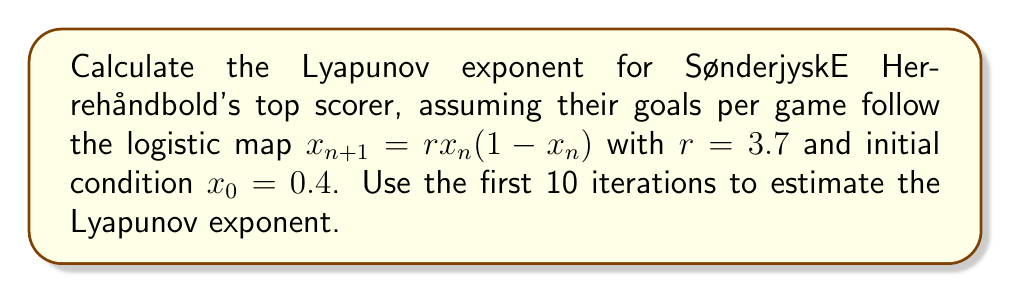Can you answer this question? To calculate the Lyapunov exponent for the player's scoring consistency, we'll follow these steps:

1) The Lyapunov exponent $\lambda$ for the logistic map is given by:

   $$\lambda = \lim_{n \to \infty} \frac{1}{n} \sum_{i=0}^{n-1} \ln |f'(x_i)|$$

   where $f'(x) = r(1-2x)$ for the logistic map.

2) We'll use the first 10 iterations to estimate $\lambda$. First, let's calculate the orbit:

   $x_0 = 0.4$
   $x_1 = 3.7 \cdot 0.4 \cdot (1-0.4) = 0.888$
   $x_2 = 3.7 \cdot 0.888 \cdot (1-0.888) = 0.368$
   $x_3 = 3.7 \cdot 0.368 \cdot (1-0.368) = 0.861$
   $x_4 = 3.7 \cdot 0.861 \cdot (1-0.861) = 0.444$
   $x_5 = 3.7 \cdot 0.444 \cdot (1-0.444) = 0.915$
   $x_6 = 3.7 \cdot 0.915 \cdot (1-0.915) = 0.288$
   $x_7 = 3.7 \cdot 0.288 \cdot (1-0.288) = 0.760$
   $x_8 = 3.7 \cdot 0.760 \cdot (1-0.760) = 0.676$
   $x_9 = 3.7 \cdot 0.676 \cdot (1-0.676) = 0.812$

3) Now, we calculate $|f'(x_i)|$ for each point:

   $|f'(x_0)| = |3.7(1-2\cdot0.4)| = 0.74$
   $|f'(x_1)| = |3.7(1-2\cdot0.888)| = 2.882$
   $|f'(x_2)| = |3.7(1-2\cdot0.368)| = 0.975$
   $|f'(x_3)| = |3.7(1-2\cdot0.861)| = 2.678$
   $|f'(x_4)| = |3.7(1-2\cdot0.444)| = 0.414$
   $|f'(x_5)| = |3.7(1-2\cdot0.915)| = 3.071$
   $|f'(x_6)| = |3.7(1-2\cdot0.288)| = 1.570$
   $|f'(x_7)| = |3.7(1-2\cdot0.760)| = 1.924$
   $|f'(x_8)| = |3.7(1-2\cdot0.676)| = 1.200$
   $|f'(x_9)| = |3.7(1-2\cdot0.812)| = 2.311$

4) We sum the logarithms of these values:

   $$\sum_{i=0}^{9} \ln |f'(x_i)| = -0.301 + 1.058 - 0.025 + 0.985 - 0.882 + 1.122 + 0.451 + 0.654 + 0.182 + 0.838 = 4.082$$

5) Finally, we divide by the number of iterations (10) to get our estimate of $\lambda$:

   $$\lambda \approx \frac{4.082}{10} = 0.4082$$
Answer: $\lambda \approx 0.4082$ 